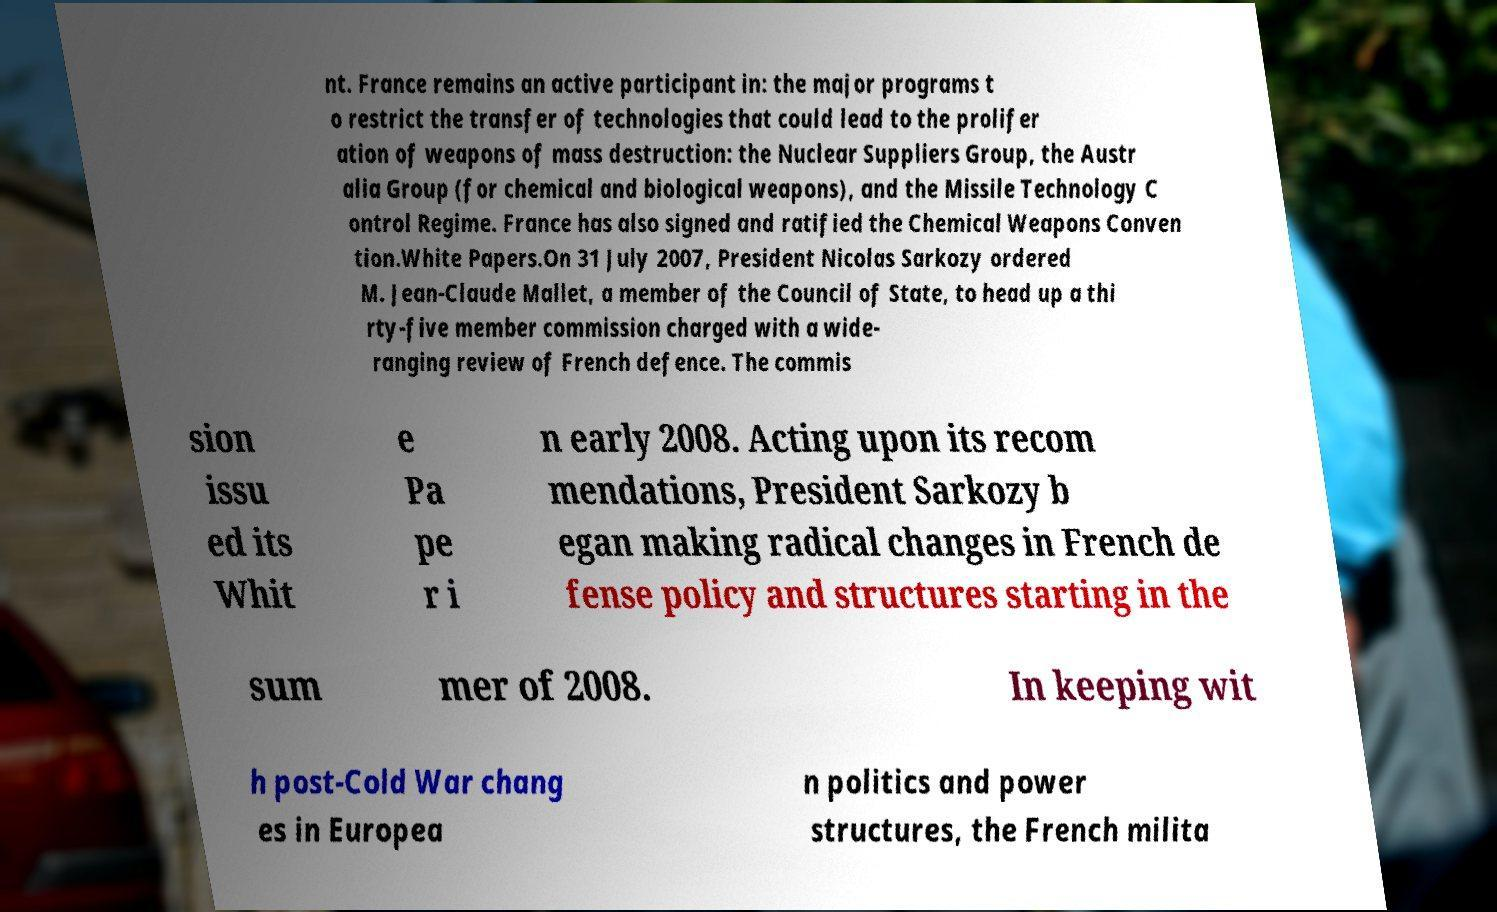There's text embedded in this image that I need extracted. Can you transcribe it verbatim? nt. France remains an active participant in: the major programs t o restrict the transfer of technologies that could lead to the prolifer ation of weapons of mass destruction: the Nuclear Suppliers Group, the Austr alia Group (for chemical and biological weapons), and the Missile Technology C ontrol Regime. France has also signed and ratified the Chemical Weapons Conven tion.White Papers.On 31 July 2007, President Nicolas Sarkozy ordered M. Jean-Claude Mallet, a member of the Council of State, to head up a thi rty-five member commission charged with a wide- ranging review of French defence. The commis sion issu ed its Whit e Pa pe r i n early 2008. Acting upon its recom mendations, President Sarkozy b egan making radical changes in French de fense policy and structures starting in the sum mer of 2008. In keeping wit h post-Cold War chang es in Europea n politics and power structures, the French milita 